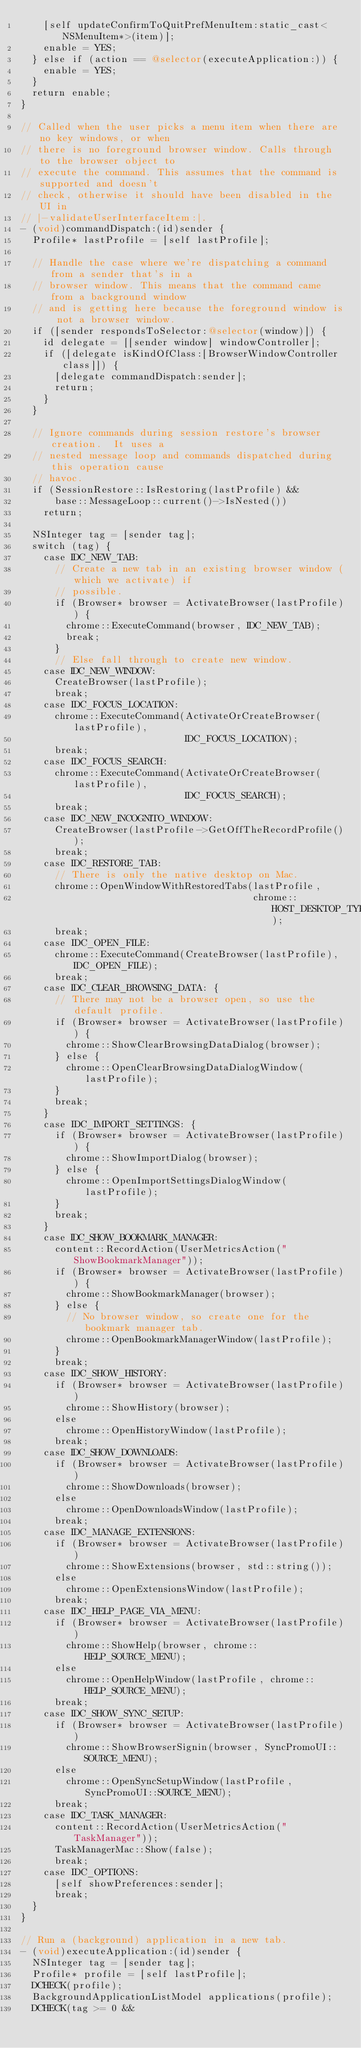Convert code to text. <code><loc_0><loc_0><loc_500><loc_500><_ObjectiveC_>    [self updateConfirmToQuitPrefMenuItem:static_cast<NSMenuItem*>(item)];
    enable = YES;
  } else if (action == @selector(executeApplication:)) {
    enable = YES;
  }
  return enable;
}

// Called when the user picks a menu item when there are no key windows, or when
// there is no foreground browser window. Calls through to the browser object to
// execute the command. This assumes that the command is supported and doesn't
// check, otherwise it should have been disabled in the UI in
// |-validateUserInterfaceItem:|.
- (void)commandDispatch:(id)sender {
  Profile* lastProfile = [self lastProfile];

  // Handle the case where we're dispatching a command from a sender that's in a
  // browser window. This means that the command came from a background window
  // and is getting here because the foreground window is not a browser window.
  if ([sender respondsToSelector:@selector(window)]) {
    id delegate = [[sender window] windowController];
    if ([delegate isKindOfClass:[BrowserWindowController class]]) {
      [delegate commandDispatch:sender];
      return;
    }
  }

  // Ignore commands during session restore's browser creation.  It uses a
  // nested message loop and commands dispatched during this operation cause
  // havoc.
  if (SessionRestore::IsRestoring(lastProfile) &&
      base::MessageLoop::current()->IsNested())
    return;

  NSInteger tag = [sender tag];
  switch (tag) {
    case IDC_NEW_TAB:
      // Create a new tab in an existing browser window (which we activate) if
      // possible.
      if (Browser* browser = ActivateBrowser(lastProfile)) {
        chrome::ExecuteCommand(browser, IDC_NEW_TAB);
        break;
      }
      // Else fall through to create new window.
    case IDC_NEW_WINDOW:
      CreateBrowser(lastProfile);
      break;
    case IDC_FOCUS_LOCATION:
      chrome::ExecuteCommand(ActivateOrCreateBrowser(lastProfile),
                             IDC_FOCUS_LOCATION);
      break;
    case IDC_FOCUS_SEARCH:
      chrome::ExecuteCommand(ActivateOrCreateBrowser(lastProfile),
                             IDC_FOCUS_SEARCH);
      break;
    case IDC_NEW_INCOGNITO_WINDOW:
      CreateBrowser(lastProfile->GetOffTheRecordProfile());
      break;
    case IDC_RESTORE_TAB:
      // There is only the native desktop on Mac.
      chrome::OpenWindowWithRestoredTabs(lastProfile,
                                         chrome::HOST_DESKTOP_TYPE_NATIVE);
      break;
    case IDC_OPEN_FILE:
      chrome::ExecuteCommand(CreateBrowser(lastProfile), IDC_OPEN_FILE);
      break;
    case IDC_CLEAR_BROWSING_DATA: {
      // There may not be a browser open, so use the default profile.
      if (Browser* browser = ActivateBrowser(lastProfile)) {
        chrome::ShowClearBrowsingDataDialog(browser);
      } else {
        chrome::OpenClearBrowsingDataDialogWindow(lastProfile);
      }
      break;
    }
    case IDC_IMPORT_SETTINGS: {
      if (Browser* browser = ActivateBrowser(lastProfile)) {
        chrome::ShowImportDialog(browser);
      } else {
        chrome::OpenImportSettingsDialogWindow(lastProfile);
      }
      break;
    }
    case IDC_SHOW_BOOKMARK_MANAGER:
      content::RecordAction(UserMetricsAction("ShowBookmarkManager"));
      if (Browser* browser = ActivateBrowser(lastProfile)) {
        chrome::ShowBookmarkManager(browser);
      } else {
        // No browser window, so create one for the bookmark manager tab.
        chrome::OpenBookmarkManagerWindow(lastProfile);
      }
      break;
    case IDC_SHOW_HISTORY:
      if (Browser* browser = ActivateBrowser(lastProfile))
        chrome::ShowHistory(browser);
      else
        chrome::OpenHistoryWindow(lastProfile);
      break;
    case IDC_SHOW_DOWNLOADS:
      if (Browser* browser = ActivateBrowser(lastProfile))
        chrome::ShowDownloads(browser);
      else
        chrome::OpenDownloadsWindow(lastProfile);
      break;
    case IDC_MANAGE_EXTENSIONS:
      if (Browser* browser = ActivateBrowser(lastProfile))
        chrome::ShowExtensions(browser, std::string());
      else
        chrome::OpenExtensionsWindow(lastProfile);
      break;
    case IDC_HELP_PAGE_VIA_MENU:
      if (Browser* browser = ActivateBrowser(lastProfile))
        chrome::ShowHelp(browser, chrome::HELP_SOURCE_MENU);
      else
        chrome::OpenHelpWindow(lastProfile, chrome::HELP_SOURCE_MENU);
      break;
    case IDC_SHOW_SYNC_SETUP:
      if (Browser* browser = ActivateBrowser(lastProfile))
        chrome::ShowBrowserSignin(browser, SyncPromoUI::SOURCE_MENU);
      else
        chrome::OpenSyncSetupWindow(lastProfile, SyncPromoUI::SOURCE_MENU);
      break;
    case IDC_TASK_MANAGER:
      content::RecordAction(UserMetricsAction("TaskManager"));
      TaskManagerMac::Show(false);
      break;
    case IDC_OPTIONS:
      [self showPreferences:sender];
      break;
  }
}

// Run a (background) application in a new tab.
- (void)executeApplication:(id)sender {
  NSInteger tag = [sender tag];
  Profile* profile = [self lastProfile];
  DCHECK(profile);
  BackgroundApplicationListModel applications(profile);
  DCHECK(tag >= 0 &&</code> 